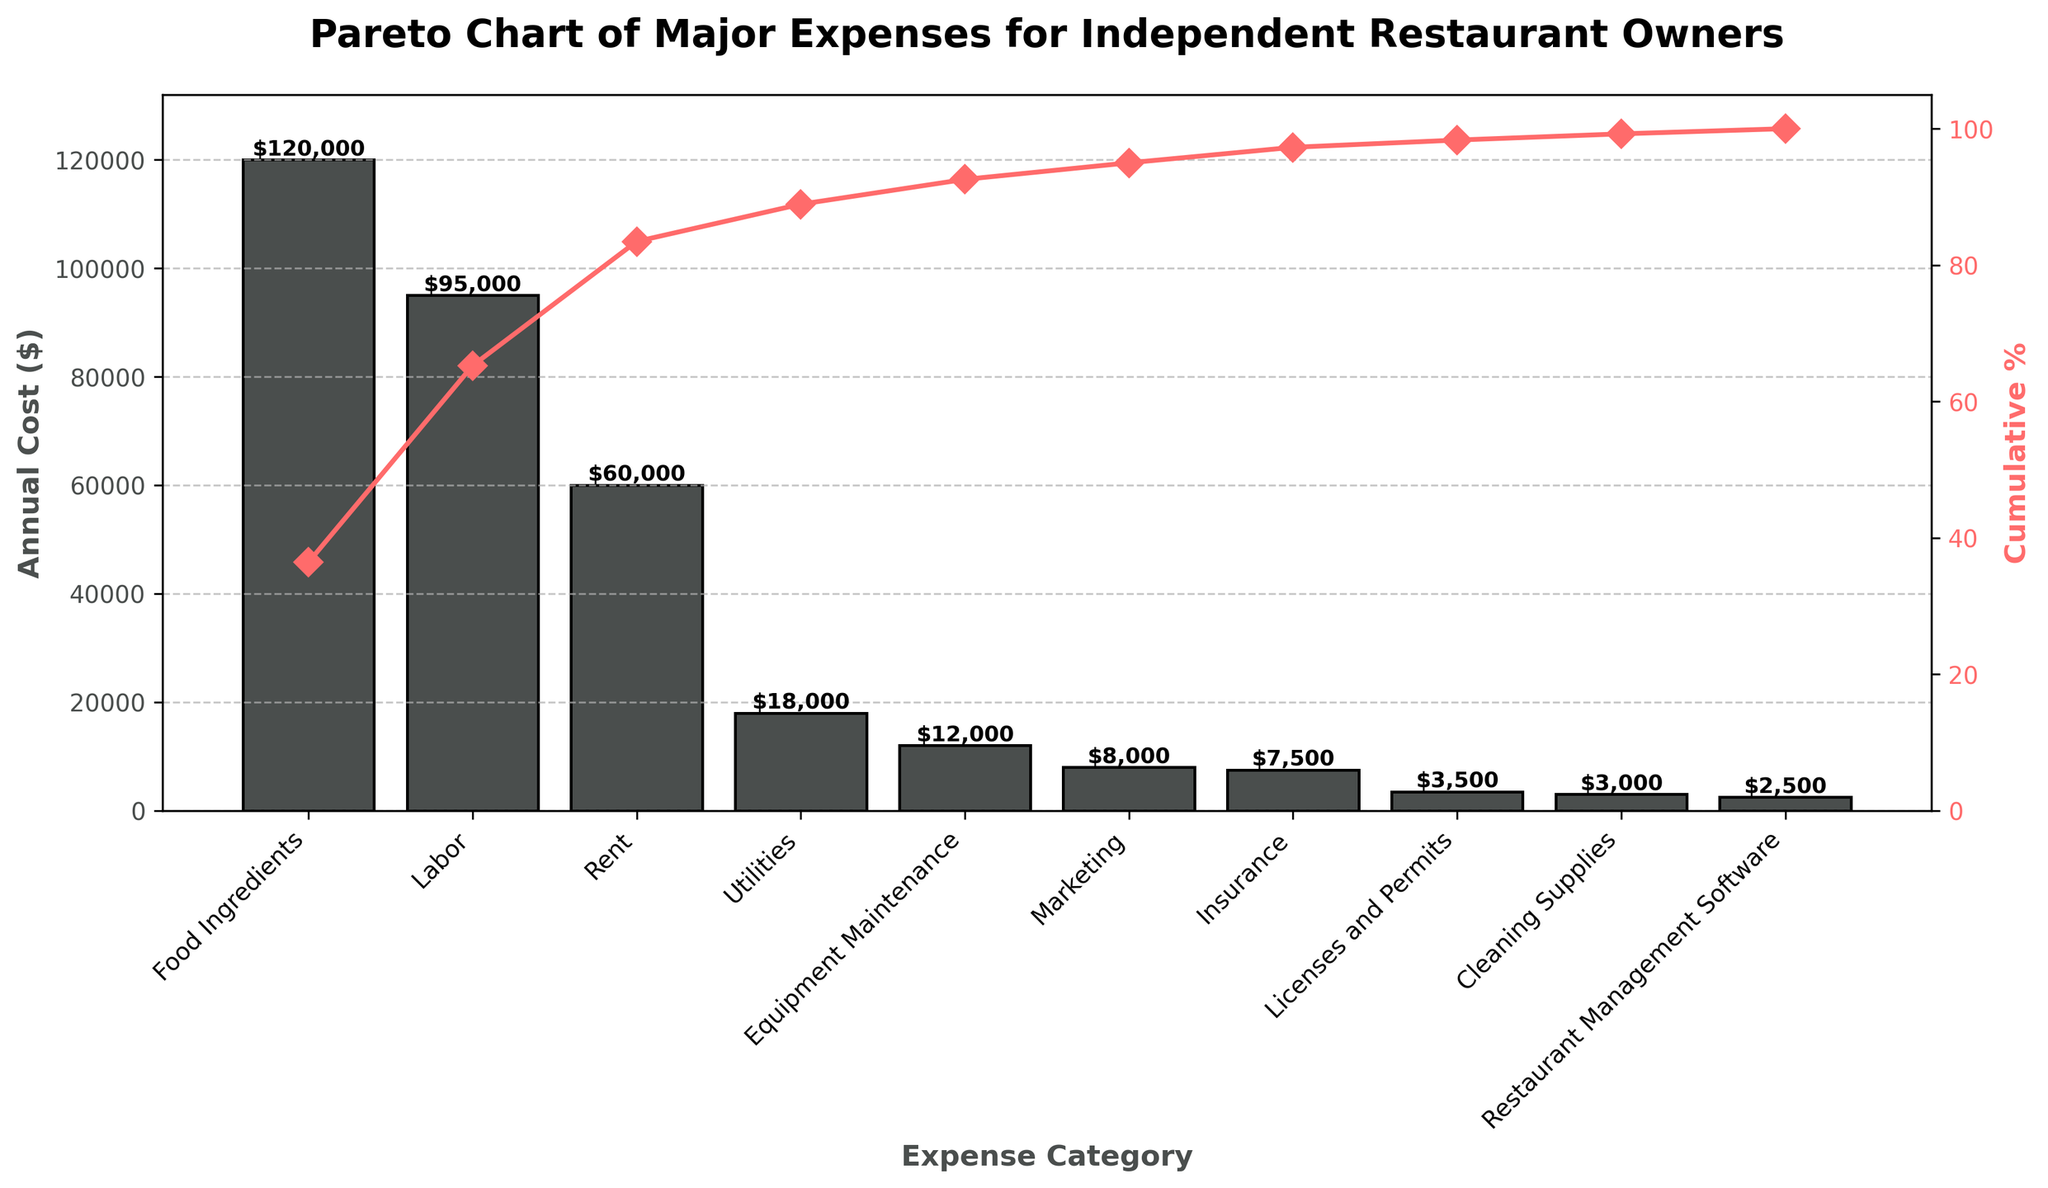What is the title of the Pareto chart? The title of the chart is usually found at the top and provides a brief description of the entire chart. In this case, it should summarize what the figure is about.
Answer: Pareto Chart of Major Expenses for Independent Restaurant Owners Which expense category has the highest annual cost? The expense category with the tallest bar represents the highest annual cost. On the Pareto chart, you will notice that the categories are sorted from highest to lowest cost. The tallest bar belongs to "Food Ingredients."
Answer: Food Ingredients What is the annual cost for labor? Identify the bar labeled "Labor" and check the height or the value label on top of the bar. This tells you the annual cost associated with labor.
Answer: $95,000 How many expense categories have an annual cost below $10,000? Look at the height of each bar and focus on those with values below $10,000. Count the bars meeting this criterion. These include Marketing, Insurance, Licenses and Permits, Cleaning Supplies, and Restaurant Management Software. There are 5 such categories.
Answer: 5 What cumulative percentage is reached by including Food Ingredients, Labor, and Rent? Locate the cumulative percentage values plotted on the secondary y-axis and follow along to the point where these three categories combine. Add the individual costs for Food Ingredients, Labor, and Rent ($120,000 + $95,000 + $60,000 = $275,000) and divide by the total sum of all categories, then multiply by 100. This should align with the cumulative percentage plotted after Rent.
Answer: 79% Which expense categories make up approximately 80% of the total annual cost? Use the cumulative percentage line to determine which categories contribute up to 80% of the total cost. Trace it visually to see which bars correspond to this percentage. Categories up to Rent make up roughly 80% of the total cost.
Answer: Food Ingredients, Labor, Rent What is the cumulative percentage after including Utilities and Equipment Maintenance? Follow the cumulative percentage line to see the value at the point where Utilities and Equipment Maintenance are included. This involves adding their costs and finding the cumulative percentage.
Answer: 92% How do the costs of Utilities and Insurance compare? Look at the heights of the bars corresponding to Utilities and Insurance. Utilities have a higher annual cost compared to Insurance.
Answer: Utilities have a higher cost What is the total annual cost for Marketing, Insurance, Licenses and Permits, and Cleaning Supplies combined? Find the individual costs for these categories and sum them up. ($8,000 + $7,500 + $3,500 + $3,000 = $22,000).
Answer: $22,000 What percentage of total annual cost does the Equipment Maintenance represent? Divide the annual cost of Equipment Maintenance by the total annual cost and multiply by 100. ($12,000 / total sum) * 100. First, calculate the total sum ($120,000 + $95,000 + $60,000 + $18,000 + $12,000 + $8,000 + $7,500 + $3,500 + $3,000 + $2,500 = $329,500). Then, ($12,000 / $329,500) * 100 = 3.64%.
Answer: 3.64% 